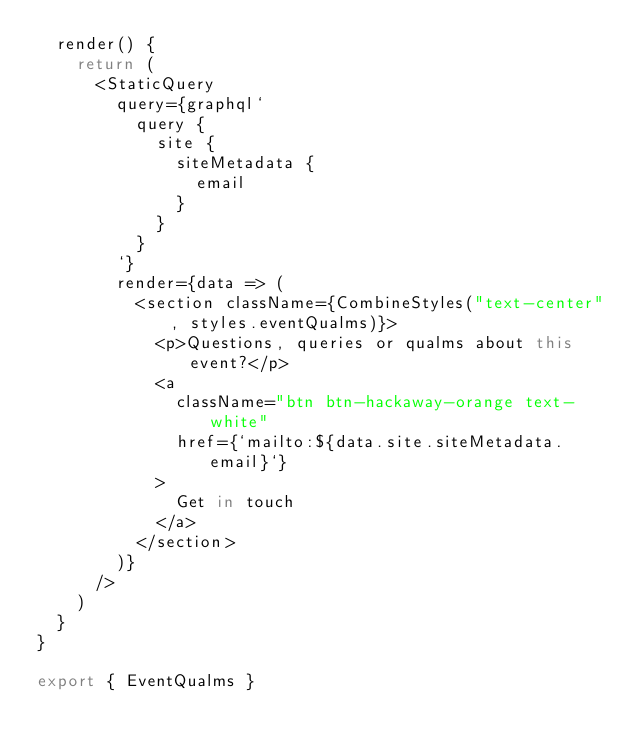Convert code to text. <code><loc_0><loc_0><loc_500><loc_500><_JavaScript_>  render() {
    return (
      <StaticQuery
        query={graphql`
          query {
            site {
              siteMetadata {
                email
              }
            }
          }
        `}
        render={data => (
          <section className={CombineStyles("text-center", styles.eventQualms)}>
            <p>Questions, queries or qualms about this event?</p>
            <a
              className="btn btn-hackaway-orange text-white"
              href={`mailto:${data.site.siteMetadata.email}`}
            >
              Get in touch
            </a>
          </section>
        )}
      />
    )
  }
}

export { EventQualms }
</code> 